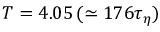Convert formula to latex. <formula><loc_0><loc_0><loc_500><loc_500>T = 4 . 0 5 \, ( \simeq 1 7 6 \tau _ { \eta } )</formula> 